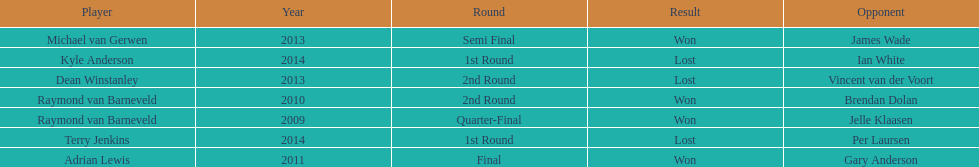Did terry jenkins or per laursen win in 2014? Per Laursen. 